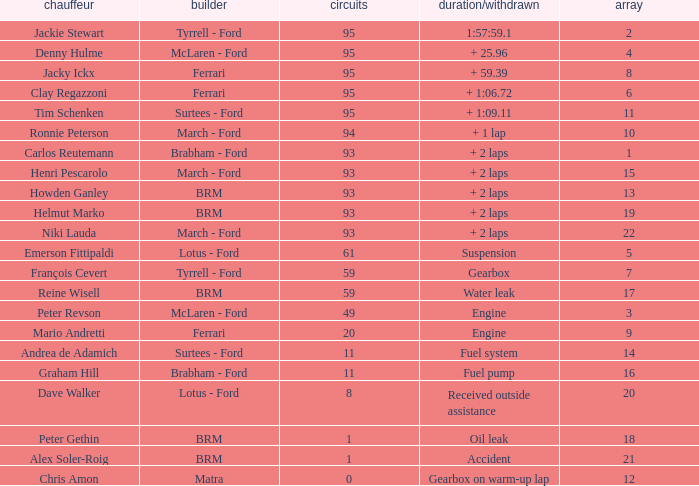What is the lowest grid with matra as constructor? 12.0. 